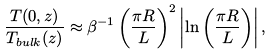Convert formula to latex. <formula><loc_0><loc_0><loc_500><loc_500>\frac { T ( 0 , z ) } { T _ { b u l k } ( z ) } \approx \beta ^ { - 1 } \left ( \frac { \pi R } { L } \right ) ^ { 2 } \left | \ln \left ( \frac { \pi R } { L } \right ) \right | ,</formula> 